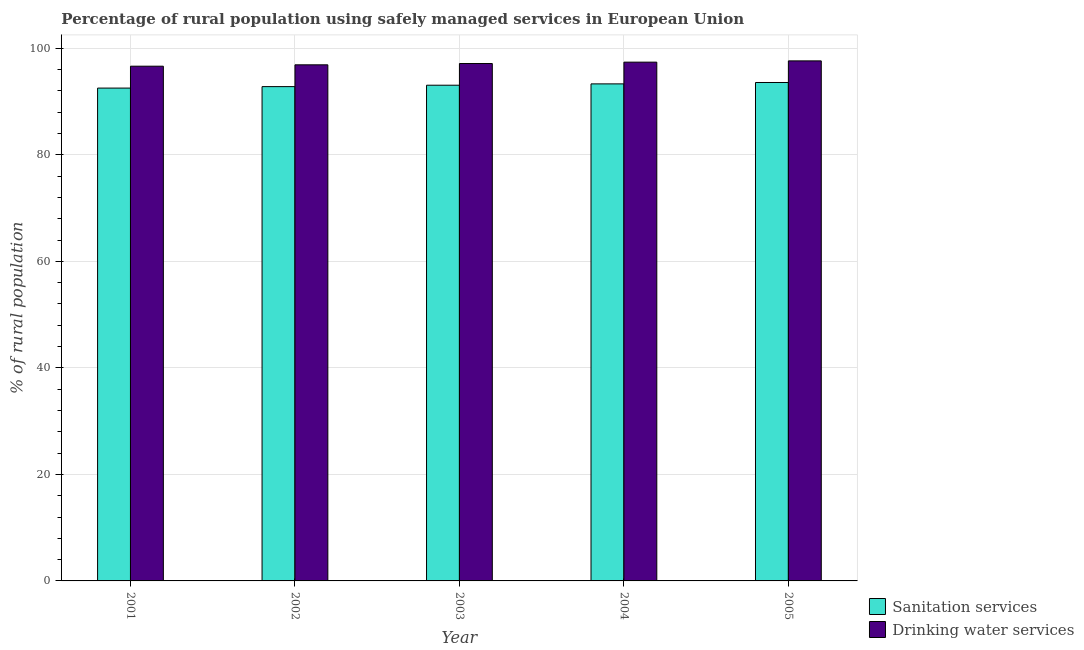How many different coloured bars are there?
Give a very brief answer. 2. How many groups of bars are there?
Your answer should be compact. 5. Are the number of bars per tick equal to the number of legend labels?
Make the answer very short. Yes. In how many cases, is the number of bars for a given year not equal to the number of legend labels?
Offer a terse response. 0. What is the percentage of rural population who used drinking water services in 2002?
Keep it short and to the point. 96.89. Across all years, what is the maximum percentage of rural population who used sanitation services?
Your response must be concise. 93.57. Across all years, what is the minimum percentage of rural population who used drinking water services?
Ensure brevity in your answer.  96.63. In which year was the percentage of rural population who used sanitation services maximum?
Offer a terse response. 2005. In which year was the percentage of rural population who used drinking water services minimum?
Offer a very short reply. 2001. What is the total percentage of rural population who used sanitation services in the graph?
Provide a succinct answer. 465.27. What is the difference between the percentage of rural population who used sanitation services in 2001 and that in 2005?
Your answer should be compact. -1.05. What is the difference between the percentage of rural population who used drinking water services in 2001 and the percentage of rural population who used sanitation services in 2002?
Make the answer very short. -0.26. What is the average percentage of rural population who used drinking water services per year?
Your answer should be very brief. 97.14. What is the ratio of the percentage of rural population who used drinking water services in 2001 to that in 2002?
Your answer should be very brief. 1. What is the difference between the highest and the second highest percentage of rural population who used sanitation services?
Provide a short and direct response. 0.26. What is the difference between the highest and the lowest percentage of rural population who used drinking water services?
Offer a terse response. 1. Is the sum of the percentage of rural population who used sanitation services in 2003 and 2004 greater than the maximum percentage of rural population who used drinking water services across all years?
Ensure brevity in your answer.  Yes. What does the 1st bar from the left in 2001 represents?
Your response must be concise. Sanitation services. What does the 1st bar from the right in 2001 represents?
Offer a very short reply. Drinking water services. Does the graph contain any zero values?
Your response must be concise. No. Where does the legend appear in the graph?
Make the answer very short. Bottom right. What is the title of the graph?
Provide a succinct answer. Percentage of rural population using safely managed services in European Union. Does "Research and Development" appear as one of the legend labels in the graph?
Keep it short and to the point. No. What is the label or title of the X-axis?
Keep it short and to the point. Year. What is the label or title of the Y-axis?
Your answer should be very brief. % of rural population. What is the % of rural population in Sanitation services in 2001?
Keep it short and to the point. 92.52. What is the % of rural population in Drinking water services in 2001?
Offer a very short reply. 96.63. What is the % of rural population of Sanitation services in 2002?
Make the answer very short. 92.8. What is the % of rural population in Drinking water services in 2002?
Offer a terse response. 96.89. What is the % of rural population of Sanitation services in 2003?
Your answer should be very brief. 93.06. What is the % of rural population of Drinking water services in 2003?
Your response must be concise. 97.13. What is the % of rural population in Sanitation services in 2004?
Your response must be concise. 93.31. What is the % of rural population in Drinking water services in 2004?
Offer a terse response. 97.39. What is the % of rural population in Sanitation services in 2005?
Offer a very short reply. 93.57. What is the % of rural population in Drinking water services in 2005?
Keep it short and to the point. 97.63. Across all years, what is the maximum % of rural population of Sanitation services?
Make the answer very short. 93.57. Across all years, what is the maximum % of rural population of Drinking water services?
Offer a terse response. 97.63. Across all years, what is the minimum % of rural population of Sanitation services?
Provide a short and direct response. 92.52. Across all years, what is the minimum % of rural population of Drinking water services?
Your answer should be very brief. 96.63. What is the total % of rural population of Sanitation services in the graph?
Your response must be concise. 465.27. What is the total % of rural population of Drinking water services in the graph?
Your answer should be very brief. 485.68. What is the difference between the % of rural population of Sanitation services in 2001 and that in 2002?
Your answer should be very brief. -0.28. What is the difference between the % of rural population of Drinking water services in 2001 and that in 2002?
Offer a terse response. -0.26. What is the difference between the % of rural population in Sanitation services in 2001 and that in 2003?
Make the answer very short. -0.54. What is the difference between the % of rural population in Drinking water services in 2001 and that in 2003?
Offer a terse response. -0.5. What is the difference between the % of rural population of Sanitation services in 2001 and that in 2004?
Ensure brevity in your answer.  -0.79. What is the difference between the % of rural population of Drinking water services in 2001 and that in 2004?
Ensure brevity in your answer.  -0.76. What is the difference between the % of rural population of Sanitation services in 2001 and that in 2005?
Offer a terse response. -1.05. What is the difference between the % of rural population in Drinking water services in 2001 and that in 2005?
Ensure brevity in your answer.  -1. What is the difference between the % of rural population of Sanitation services in 2002 and that in 2003?
Your answer should be compact. -0.26. What is the difference between the % of rural population in Drinking water services in 2002 and that in 2003?
Offer a terse response. -0.24. What is the difference between the % of rural population in Sanitation services in 2002 and that in 2004?
Your answer should be compact. -0.51. What is the difference between the % of rural population of Drinking water services in 2002 and that in 2004?
Provide a succinct answer. -0.5. What is the difference between the % of rural population in Sanitation services in 2002 and that in 2005?
Your answer should be compact. -0.77. What is the difference between the % of rural population in Drinking water services in 2002 and that in 2005?
Your answer should be very brief. -0.74. What is the difference between the % of rural population of Sanitation services in 2003 and that in 2004?
Give a very brief answer. -0.25. What is the difference between the % of rural population of Drinking water services in 2003 and that in 2004?
Provide a succinct answer. -0.26. What is the difference between the % of rural population of Sanitation services in 2003 and that in 2005?
Your answer should be compact. -0.51. What is the difference between the % of rural population of Drinking water services in 2003 and that in 2005?
Ensure brevity in your answer.  -0.5. What is the difference between the % of rural population of Sanitation services in 2004 and that in 2005?
Your answer should be compact. -0.26. What is the difference between the % of rural population of Drinking water services in 2004 and that in 2005?
Provide a succinct answer. -0.24. What is the difference between the % of rural population in Sanitation services in 2001 and the % of rural population in Drinking water services in 2002?
Ensure brevity in your answer.  -4.37. What is the difference between the % of rural population in Sanitation services in 2001 and the % of rural population in Drinking water services in 2003?
Ensure brevity in your answer.  -4.61. What is the difference between the % of rural population of Sanitation services in 2001 and the % of rural population of Drinking water services in 2004?
Provide a short and direct response. -4.87. What is the difference between the % of rural population in Sanitation services in 2001 and the % of rural population in Drinking water services in 2005?
Your response must be concise. -5.11. What is the difference between the % of rural population of Sanitation services in 2002 and the % of rural population of Drinking water services in 2003?
Give a very brief answer. -4.33. What is the difference between the % of rural population in Sanitation services in 2002 and the % of rural population in Drinking water services in 2004?
Ensure brevity in your answer.  -4.59. What is the difference between the % of rural population in Sanitation services in 2002 and the % of rural population in Drinking water services in 2005?
Your response must be concise. -4.83. What is the difference between the % of rural population of Sanitation services in 2003 and the % of rural population of Drinking water services in 2004?
Offer a very short reply. -4.33. What is the difference between the % of rural population in Sanitation services in 2003 and the % of rural population in Drinking water services in 2005?
Provide a short and direct response. -4.57. What is the difference between the % of rural population of Sanitation services in 2004 and the % of rural population of Drinking water services in 2005?
Provide a short and direct response. -4.32. What is the average % of rural population of Sanitation services per year?
Keep it short and to the point. 93.05. What is the average % of rural population of Drinking water services per year?
Keep it short and to the point. 97.14. In the year 2001, what is the difference between the % of rural population in Sanitation services and % of rural population in Drinking water services?
Ensure brevity in your answer.  -4.11. In the year 2002, what is the difference between the % of rural population in Sanitation services and % of rural population in Drinking water services?
Give a very brief answer. -4.09. In the year 2003, what is the difference between the % of rural population of Sanitation services and % of rural population of Drinking water services?
Provide a succinct answer. -4.07. In the year 2004, what is the difference between the % of rural population of Sanitation services and % of rural population of Drinking water services?
Make the answer very short. -4.08. In the year 2005, what is the difference between the % of rural population of Sanitation services and % of rural population of Drinking water services?
Provide a succinct answer. -4.06. What is the ratio of the % of rural population in Drinking water services in 2001 to that in 2003?
Give a very brief answer. 0.99. What is the ratio of the % of rural population in Sanitation services in 2001 to that in 2004?
Your answer should be very brief. 0.99. What is the ratio of the % of rural population in Sanitation services in 2001 to that in 2005?
Provide a short and direct response. 0.99. What is the ratio of the % of rural population of Sanitation services in 2002 to that in 2003?
Give a very brief answer. 1. What is the ratio of the % of rural population in Sanitation services in 2002 to that in 2004?
Your answer should be very brief. 0.99. What is the ratio of the % of rural population of Drinking water services in 2002 to that in 2005?
Keep it short and to the point. 0.99. What is the ratio of the % of rural population of Drinking water services in 2003 to that in 2004?
Keep it short and to the point. 1. What is the ratio of the % of rural population in Sanitation services in 2003 to that in 2005?
Make the answer very short. 0.99. What is the ratio of the % of rural population of Sanitation services in 2004 to that in 2005?
Keep it short and to the point. 1. What is the ratio of the % of rural population in Drinking water services in 2004 to that in 2005?
Ensure brevity in your answer.  1. What is the difference between the highest and the second highest % of rural population of Sanitation services?
Give a very brief answer. 0.26. What is the difference between the highest and the second highest % of rural population in Drinking water services?
Your answer should be compact. 0.24. What is the difference between the highest and the lowest % of rural population in Sanitation services?
Make the answer very short. 1.05. What is the difference between the highest and the lowest % of rural population of Drinking water services?
Provide a short and direct response. 1. 